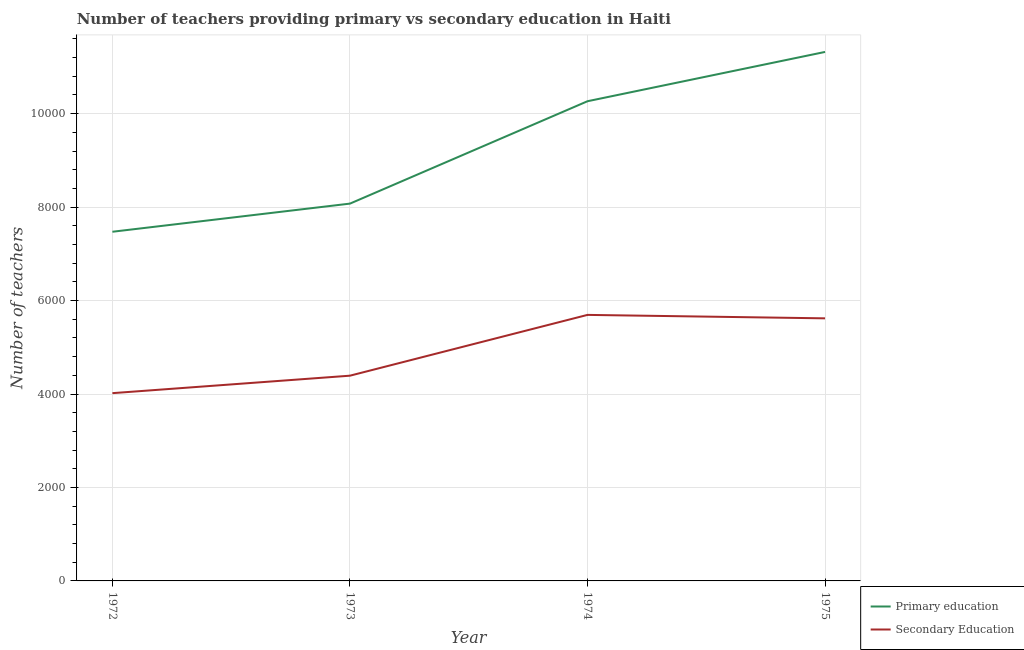How many different coloured lines are there?
Your response must be concise. 2. Does the line corresponding to number of primary teachers intersect with the line corresponding to number of secondary teachers?
Ensure brevity in your answer.  No. What is the number of primary teachers in 1975?
Provide a short and direct response. 1.13e+04. Across all years, what is the maximum number of secondary teachers?
Provide a succinct answer. 5693. Across all years, what is the minimum number of primary teachers?
Provide a succinct answer. 7472. In which year was the number of secondary teachers maximum?
Your answer should be very brief. 1974. What is the total number of primary teachers in the graph?
Your answer should be very brief. 3.71e+04. What is the difference between the number of secondary teachers in 1973 and that in 1974?
Provide a short and direct response. -1301. What is the difference between the number of primary teachers in 1974 and the number of secondary teachers in 1972?
Offer a very short reply. 6247. What is the average number of primary teachers per year?
Provide a succinct answer. 9282.75. In the year 1975, what is the difference between the number of primary teachers and number of secondary teachers?
Keep it short and to the point. 5701. In how many years, is the number of primary teachers greater than 3200?
Your answer should be very brief. 4. What is the ratio of the number of secondary teachers in 1974 to that in 1975?
Offer a terse response. 1.01. Is the difference between the number of secondary teachers in 1972 and 1975 greater than the difference between the number of primary teachers in 1972 and 1975?
Give a very brief answer. Yes. What is the difference between the highest and the second highest number of secondary teachers?
Ensure brevity in your answer.  74. What is the difference between the highest and the lowest number of secondary teachers?
Give a very brief answer. 1675. Does the graph contain any zero values?
Make the answer very short. No. Where does the legend appear in the graph?
Your answer should be compact. Bottom right. How many legend labels are there?
Give a very brief answer. 2. What is the title of the graph?
Offer a very short reply. Number of teachers providing primary vs secondary education in Haiti. What is the label or title of the X-axis?
Ensure brevity in your answer.  Year. What is the label or title of the Y-axis?
Your answer should be compact. Number of teachers. What is the Number of teachers in Primary education in 1972?
Give a very brief answer. 7472. What is the Number of teachers of Secondary Education in 1972?
Make the answer very short. 4018. What is the Number of teachers of Primary education in 1973?
Offer a terse response. 8074. What is the Number of teachers in Secondary Education in 1973?
Make the answer very short. 4392. What is the Number of teachers in Primary education in 1974?
Give a very brief answer. 1.03e+04. What is the Number of teachers of Secondary Education in 1974?
Your answer should be very brief. 5693. What is the Number of teachers of Primary education in 1975?
Offer a very short reply. 1.13e+04. What is the Number of teachers of Secondary Education in 1975?
Your answer should be compact. 5619. Across all years, what is the maximum Number of teachers in Primary education?
Your response must be concise. 1.13e+04. Across all years, what is the maximum Number of teachers of Secondary Education?
Keep it short and to the point. 5693. Across all years, what is the minimum Number of teachers in Primary education?
Ensure brevity in your answer.  7472. Across all years, what is the minimum Number of teachers of Secondary Education?
Your answer should be compact. 4018. What is the total Number of teachers in Primary education in the graph?
Provide a succinct answer. 3.71e+04. What is the total Number of teachers in Secondary Education in the graph?
Offer a terse response. 1.97e+04. What is the difference between the Number of teachers in Primary education in 1972 and that in 1973?
Your answer should be compact. -602. What is the difference between the Number of teachers of Secondary Education in 1972 and that in 1973?
Your answer should be very brief. -374. What is the difference between the Number of teachers of Primary education in 1972 and that in 1974?
Give a very brief answer. -2793. What is the difference between the Number of teachers in Secondary Education in 1972 and that in 1974?
Give a very brief answer. -1675. What is the difference between the Number of teachers of Primary education in 1972 and that in 1975?
Your answer should be compact. -3848. What is the difference between the Number of teachers in Secondary Education in 1972 and that in 1975?
Ensure brevity in your answer.  -1601. What is the difference between the Number of teachers in Primary education in 1973 and that in 1974?
Your answer should be very brief. -2191. What is the difference between the Number of teachers in Secondary Education in 1973 and that in 1974?
Your response must be concise. -1301. What is the difference between the Number of teachers of Primary education in 1973 and that in 1975?
Your answer should be compact. -3246. What is the difference between the Number of teachers in Secondary Education in 1973 and that in 1975?
Your response must be concise. -1227. What is the difference between the Number of teachers in Primary education in 1974 and that in 1975?
Make the answer very short. -1055. What is the difference between the Number of teachers in Primary education in 1972 and the Number of teachers in Secondary Education in 1973?
Your response must be concise. 3080. What is the difference between the Number of teachers in Primary education in 1972 and the Number of teachers in Secondary Education in 1974?
Provide a succinct answer. 1779. What is the difference between the Number of teachers in Primary education in 1972 and the Number of teachers in Secondary Education in 1975?
Offer a terse response. 1853. What is the difference between the Number of teachers in Primary education in 1973 and the Number of teachers in Secondary Education in 1974?
Provide a short and direct response. 2381. What is the difference between the Number of teachers of Primary education in 1973 and the Number of teachers of Secondary Education in 1975?
Offer a terse response. 2455. What is the difference between the Number of teachers in Primary education in 1974 and the Number of teachers in Secondary Education in 1975?
Your response must be concise. 4646. What is the average Number of teachers of Primary education per year?
Make the answer very short. 9282.75. What is the average Number of teachers in Secondary Education per year?
Your answer should be very brief. 4930.5. In the year 1972, what is the difference between the Number of teachers in Primary education and Number of teachers in Secondary Education?
Offer a very short reply. 3454. In the year 1973, what is the difference between the Number of teachers of Primary education and Number of teachers of Secondary Education?
Your response must be concise. 3682. In the year 1974, what is the difference between the Number of teachers of Primary education and Number of teachers of Secondary Education?
Your answer should be compact. 4572. In the year 1975, what is the difference between the Number of teachers of Primary education and Number of teachers of Secondary Education?
Make the answer very short. 5701. What is the ratio of the Number of teachers of Primary education in 1972 to that in 1973?
Your response must be concise. 0.93. What is the ratio of the Number of teachers of Secondary Education in 1972 to that in 1973?
Offer a terse response. 0.91. What is the ratio of the Number of teachers in Primary education in 1972 to that in 1974?
Ensure brevity in your answer.  0.73. What is the ratio of the Number of teachers of Secondary Education in 1972 to that in 1974?
Your answer should be compact. 0.71. What is the ratio of the Number of teachers of Primary education in 1972 to that in 1975?
Provide a succinct answer. 0.66. What is the ratio of the Number of teachers in Secondary Education in 1972 to that in 1975?
Your answer should be compact. 0.72. What is the ratio of the Number of teachers of Primary education in 1973 to that in 1974?
Provide a short and direct response. 0.79. What is the ratio of the Number of teachers in Secondary Education in 1973 to that in 1974?
Ensure brevity in your answer.  0.77. What is the ratio of the Number of teachers of Primary education in 1973 to that in 1975?
Provide a short and direct response. 0.71. What is the ratio of the Number of teachers in Secondary Education in 1973 to that in 1975?
Ensure brevity in your answer.  0.78. What is the ratio of the Number of teachers of Primary education in 1974 to that in 1975?
Ensure brevity in your answer.  0.91. What is the ratio of the Number of teachers in Secondary Education in 1974 to that in 1975?
Your answer should be compact. 1.01. What is the difference between the highest and the second highest Number of teachers of Primary education?
Provide a short and direct response. 1055. What is the difference between the highest and the lowest Number of teachers in Primary education?
Your response must be concise. 3848. What is the difference between the highest and the lowest Number of teachers of Secondary Education?
Your answer should be compact. 1675. 